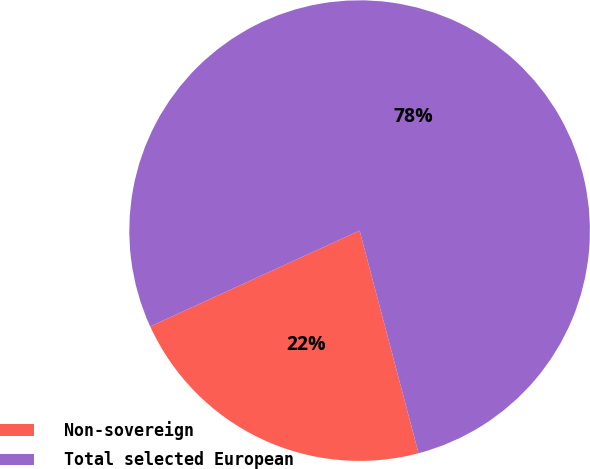Convert chart. <chart><loc_0><loc_0><loc_500><loc_500><pie_chart><fcel>Non-sovereign<fcel>Total selected European<nl><fcel>22.29%<fcel>77.71%<nl></chart> 